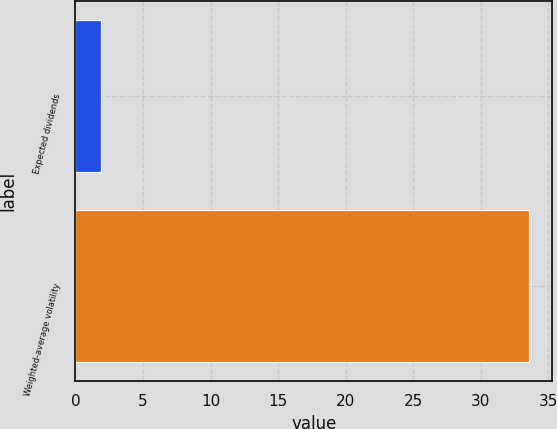<chart> <loc_0><loc_0><loc_500><loc_500><bar_chart><fcel>Expected dividends<fcel>Weighted-average volatility<nl><fcel>1.9<fcel>33.6<nl></chart> 